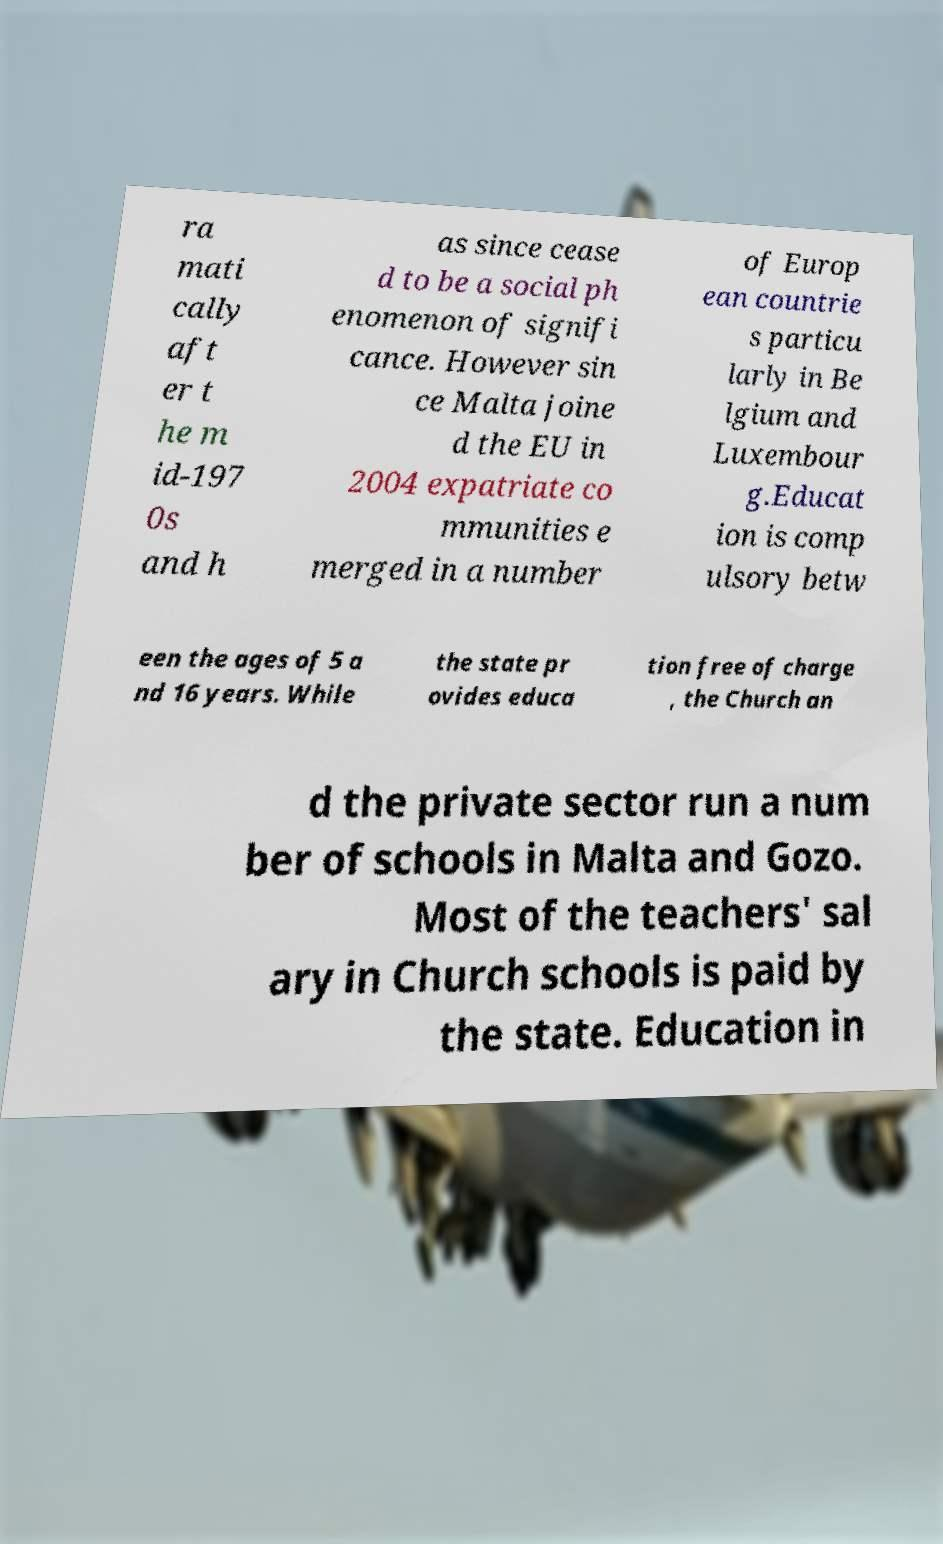Could you assist in decoding the text presented in this image and type it out clearly? ra mati cally aft er t he m id-197 0s and h as since cease d to be a social ph enomenon of signifi cance. However sin ce Malta joine d the EU in 2004 expatriate co mmunities e merged in a number of Europ ean countrie s particu larly in Be lgium and Luxembour g.Educat ion is comp ulsory betw een the ages of 5 a nd 16 years. While the state pr ovides educa tion free of charge , the Church an d the private sector run a num ber of schools in Malta and Gozo. Most of the teachers' sal ary in Church schools is paid by the state. Education in 